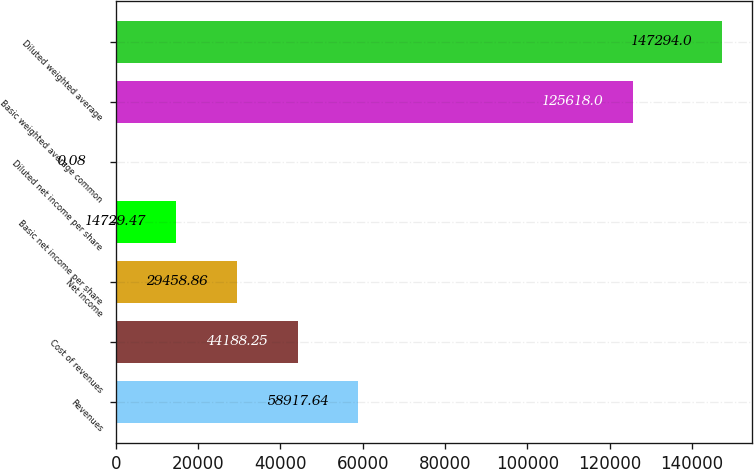Convert chart. <chart><loc_0><loc_0><loc_500><loc_500><bar_chart><fcel>Revenues<fcel>Cost of revenues<fcel>Net income<fcel>Basic net income per share<fcel>Diluted net income per share<fcel>Basic weighted average common<fcel>Diluted weighted average<nl><fcel>58917.6<fcel>44188.2<fcel>29458.9<fcel>14729.5<fcel>0.08<fcel>125618<fcel>147294<nl></chart> 